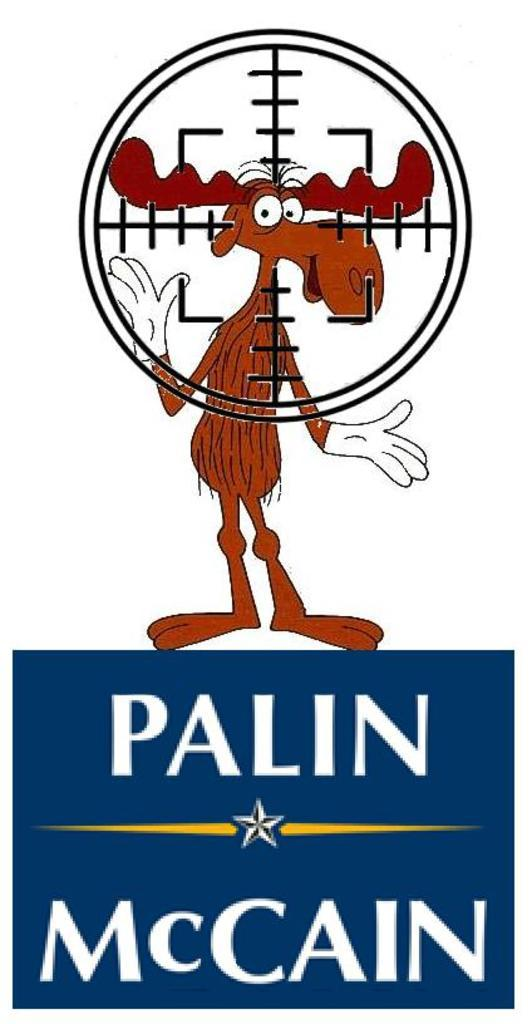<image>
Summarize the visual content of the image. Bullwinkle the moose standing on a Palin and McCain advertisement. 